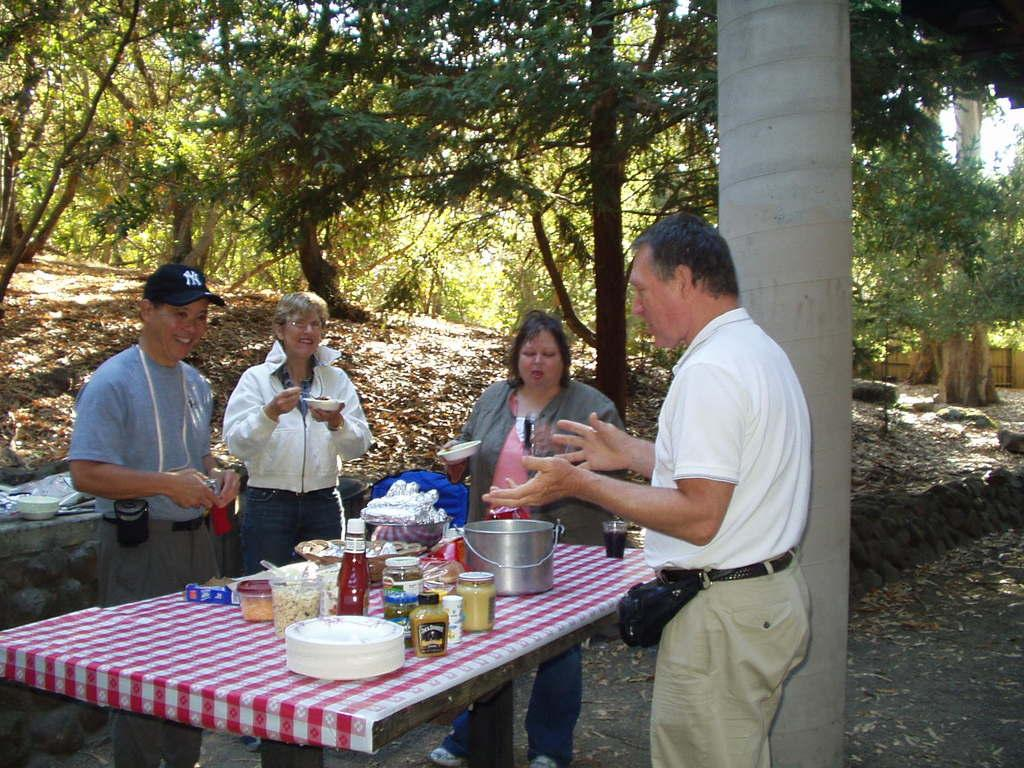How many people are standing on the table in the image? There are four people standing on the table in the image. What type of tableware can be seen in the image? There are plates, bowls, and glasses in the image. What is present on the tableware? There is food in the image. What can be seen in the background of the image? There are trees visible in the background of the image. What type of grass is being used as a storytelling prop in the image? There is no grass or storytelling prop present in the image. 